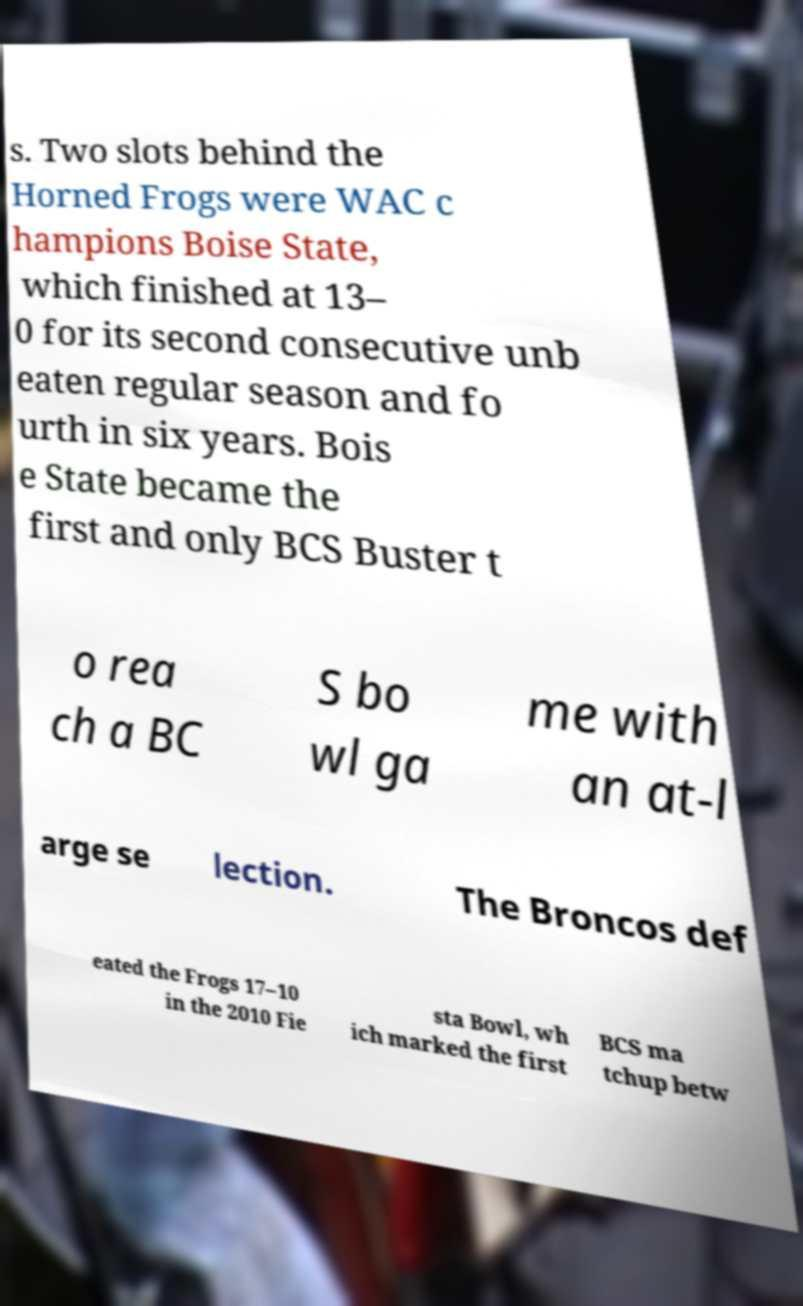There's text embedded in this image that I need extracted. Can you transcribe it verbatim? s. Two slots behind the Horned Frogs were WAC c hampions Boise State, which finished at 13– 0 for its second consecutive unb eaten regular season and fo urth in six years. Bois e State became the first and only BCS Buster t o rea ch a BC S bo wl ga me with an at-l arge se lection. The Broncos def eated the Frogs 17–10 in the 2010 Fie sta Bowl, wh ich marked the first BCS ma tchup betw 